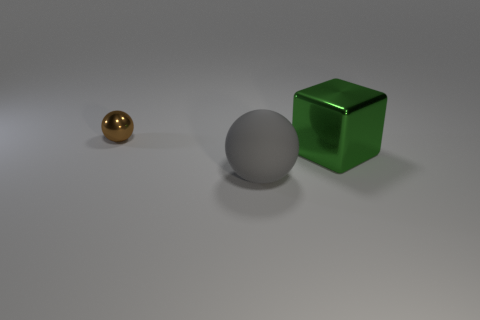Add 2 green things. How many objects exist? 5 Subtract all balls. How many objects are left? 1 Add 1 green things. How many green things exist? 2 Subtract 0 purple spheres. How many objects are left? 3 Subtract all big purple shiny balls. Subtract all big green metal things. How many objects are left? 2 Add 3 large gray balls. How many large gray balls are left? 4 